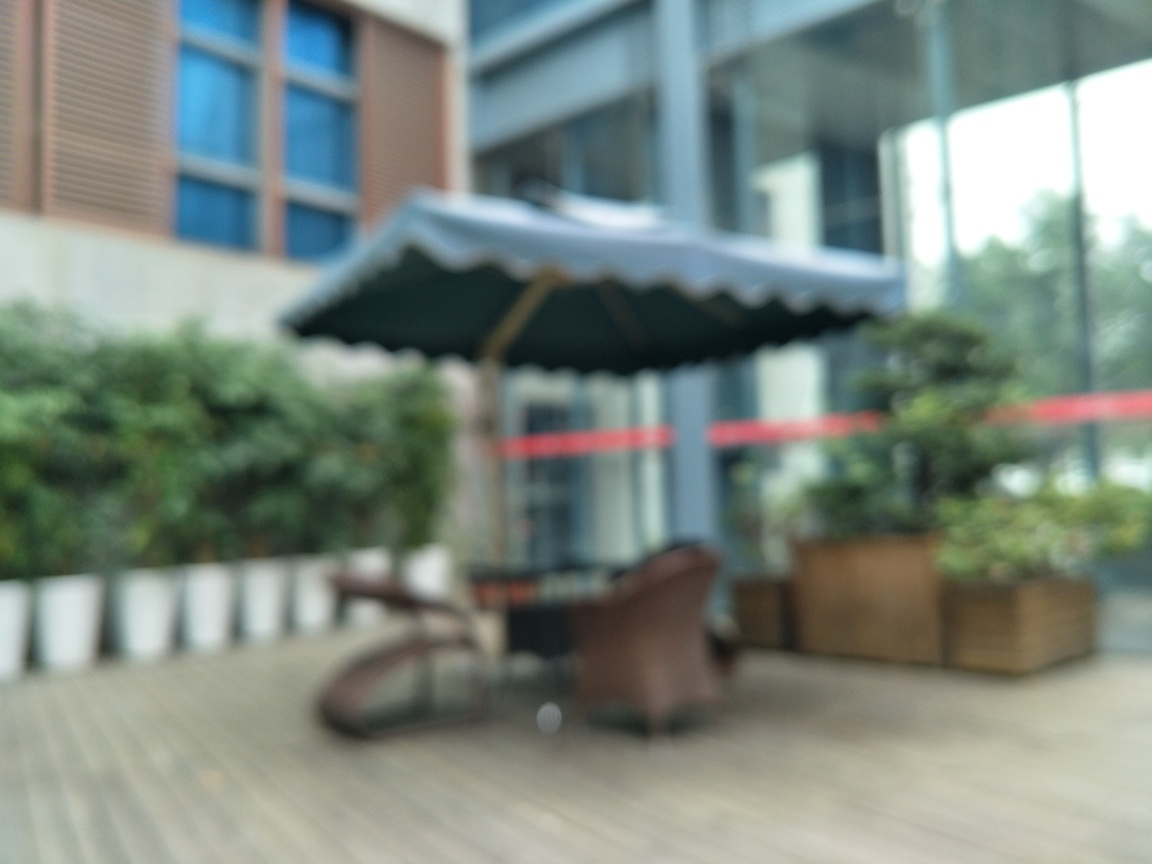If this image were part of a visual story, what themes might it convey? Given the image's blurred aesthetic, it could represent themes of memory, the passage of time, or the subjective nature of perception. It might symbolize the idea that life's details can sometimes be obscured, or how moments can fade into a hazy memory. 